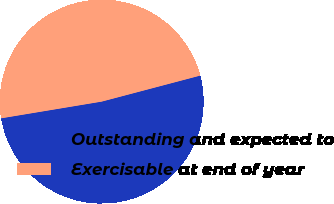Convert chart. <chart><loc_0><loc_0><loc_500><loc_500><pie_chart><fcel>Outstanding and expected to<fcel>Exercisable at end of year<nl><fcel>51.49%<fcel>48.51%<nl></chart> 